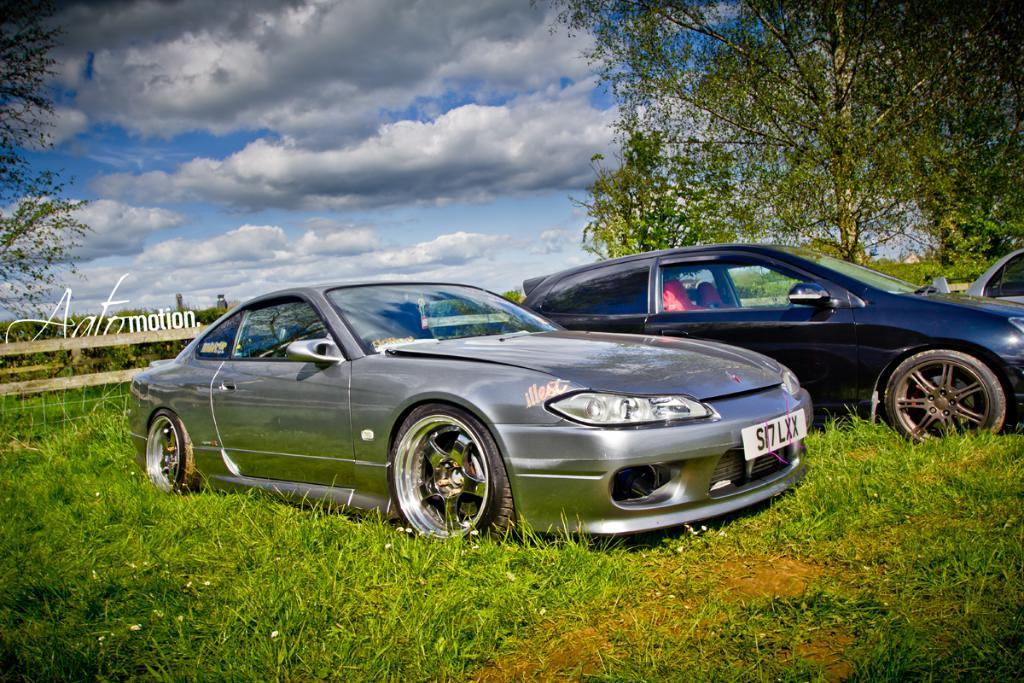What type of vegetation is present on the ground in the center of the image? There is grass on the ground in the center of the image. What can be seen in the background of the image? There is fencing, trees, and the sky visible in the background of the image. What is the condition of the sky in the image? Clouds are present in the sky in the image. How many dolls are sitting on the grass in the image? There are no dolls present in the image; it features grass on the ground in the center. 